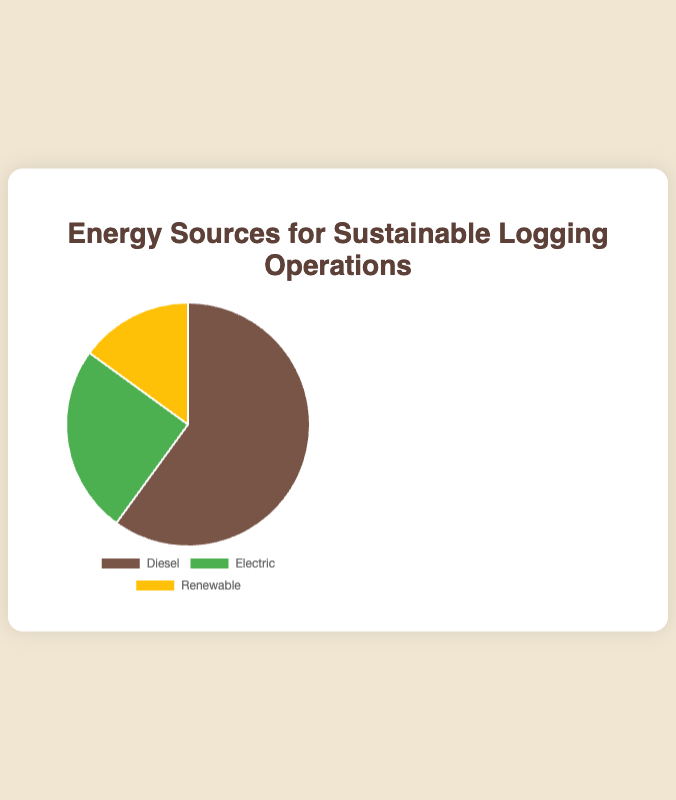What percentage of the energy sources is Diesel? The pie chart shows different energy sources and their respective percentages. The segment labeled "Diesel" occupies 60% of the chart.
Answer: 60% Which energy source is used the least? By examining the pie chart, it is clear that the segment labeled "Renewable" is the smallest, occupying only 15% of the chart.
Answer: Renewable Is the percentage of Diesel usage greater than the combined percentage of Electric and Renewable? The Diesel segment is 60%. The combined percentage for Electric and Renewable is 25% + 15% = 40%. Therefore, Diesel usage (60%) is greater than Electric and Renewable combined (40%).
Answer: Yes How much less is the percentage of Renewable energy compared to Electric energy? Renewable energy accounts for 15%, and Electric energy accounts for 25%. The difference is 25% - 15% = 10%.
Answer: 10% What percentage of the energy sources is non-diesel? The Diesel segment is 60%, so the non-diesel sources must be 100% - 60% = 40%. This can be confirmed by adding the percentages for Electric and Renewable: 25% + 15% = 40%.
Answer: 40% What color represents the Electric energy source in the pie chart? In the legend of the pie chart, Electric energy is represented by green.
Answer: Green Among Diesel, Electric, and Renewable, which two energy sources together make up half of the total energy usage? The total percentage is 100%. Looking at the segments, Electric (25%) and Renewable (15%) together make 25% + 15% = 40%. Diesel (60%) alone is not paired with another source to make up exactly half, but combining Diesel’s 60% with any other smaller value (e.g., Electric or Renewable) results in a total over 50%.
Answer: None Which energy source is represented by the color yellow in the pie chart? The legend in the pie chart shows that Renewable energy is represented by yellow.
Answer: Renewable If the usage of Diesel was reduced by 10% and the same amount was added to Renewable, what would the new percentages be for Diesel and Renewable? Initially, Diesel is 60% and Renewable is 15%. Reducing Diesel by 10% results in 60% - 10% = 50%. Adding this 10% to Renewable makes it 15% + 10% = 25%.
Answer: Diesel: 50%, Renewable: 25% How many percentage points more is Diesel than Electric? Diesel energy usage is 60%, and Electric energy usage is 25%. The difference between the two is 60% - 25% = 35%.
Answer: 35% 